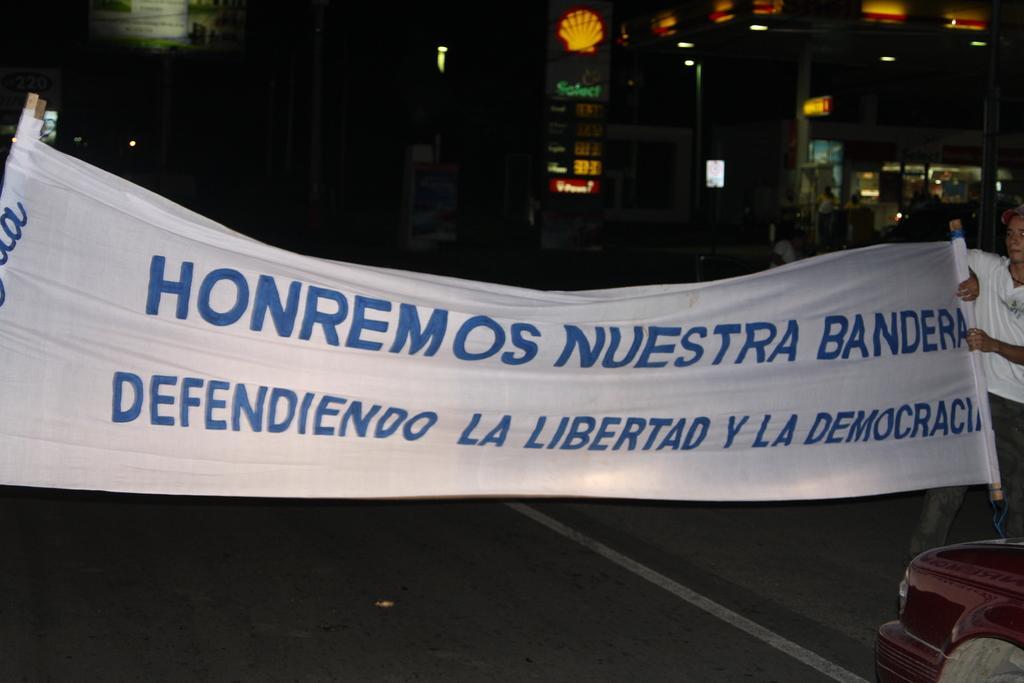Please provide a concise description of this image. This is an image clicked in the dark. On the right side a man standing and holding a banner in the hands. On the banner, I can see some text. In the background there are some buildings in the dark. 